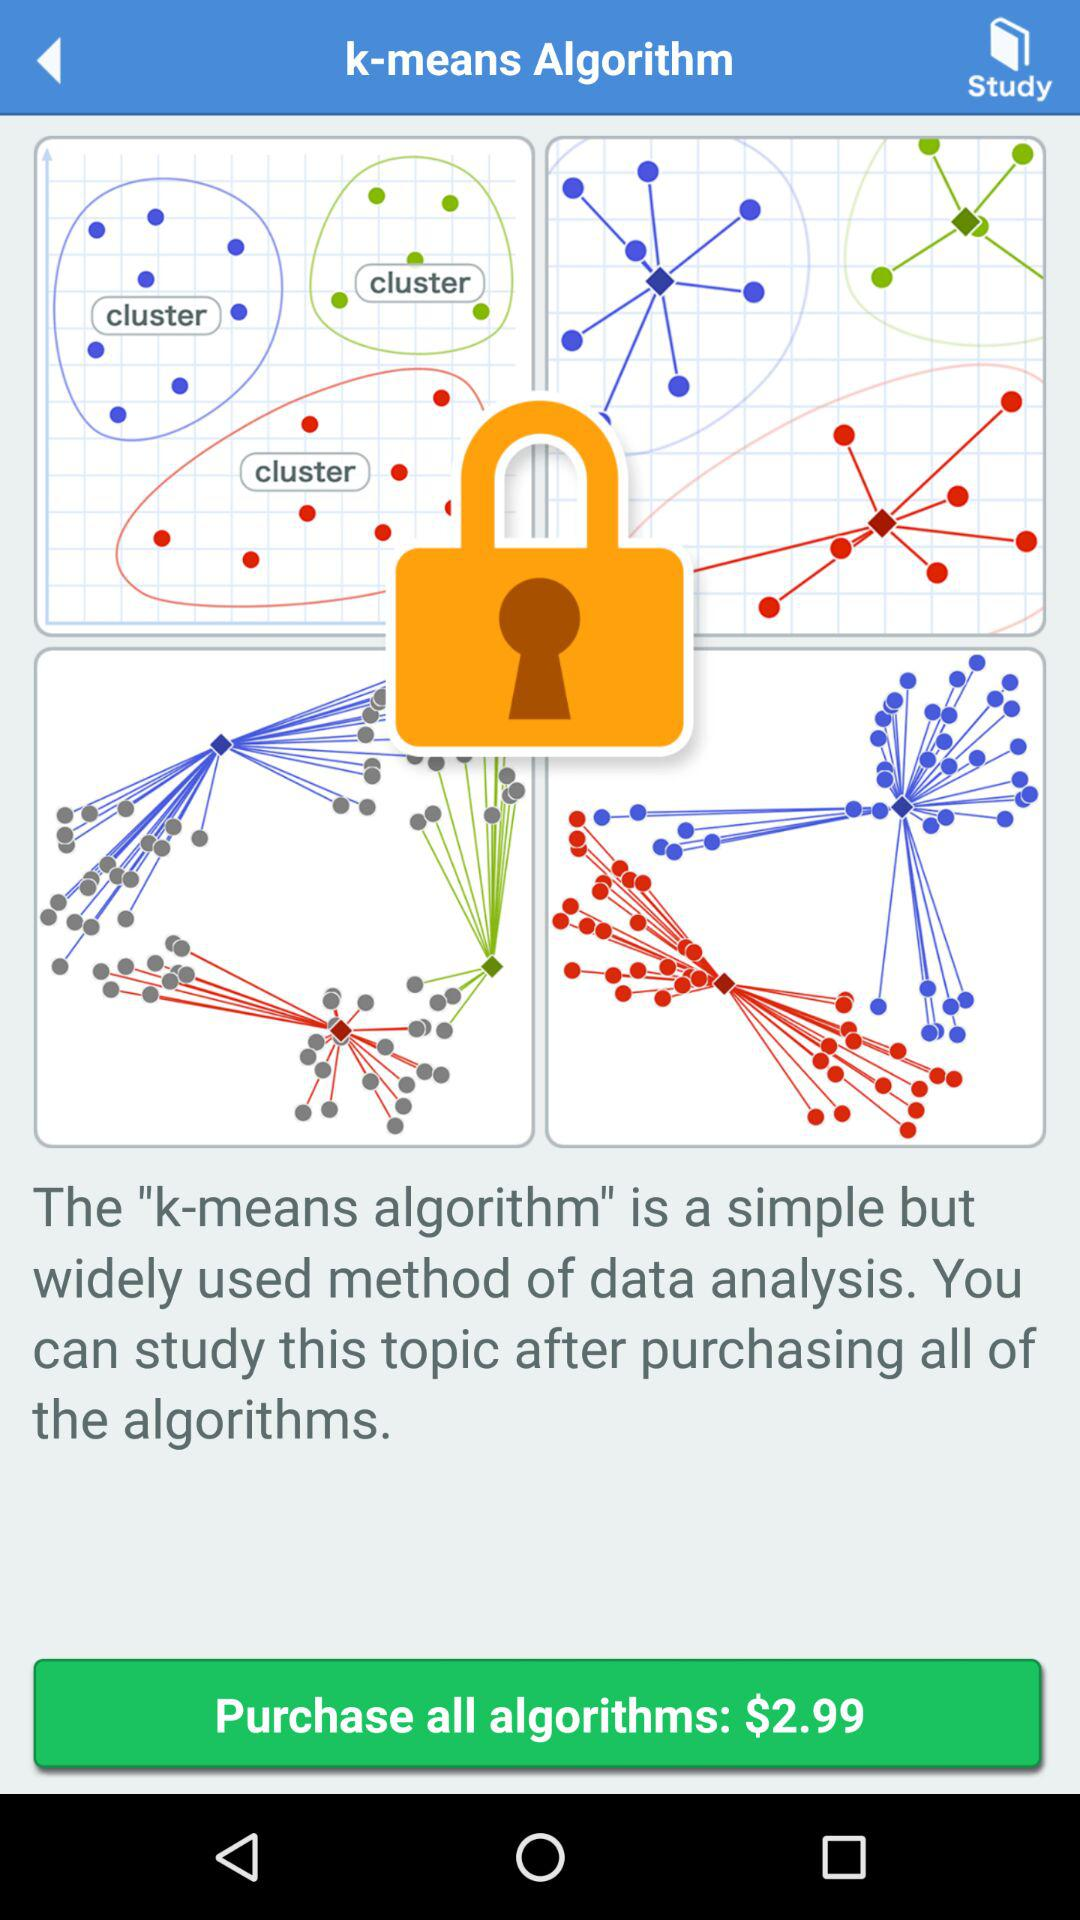What is the purchase price of the algorithms? The purchase price of the algorithms is $2.99. 